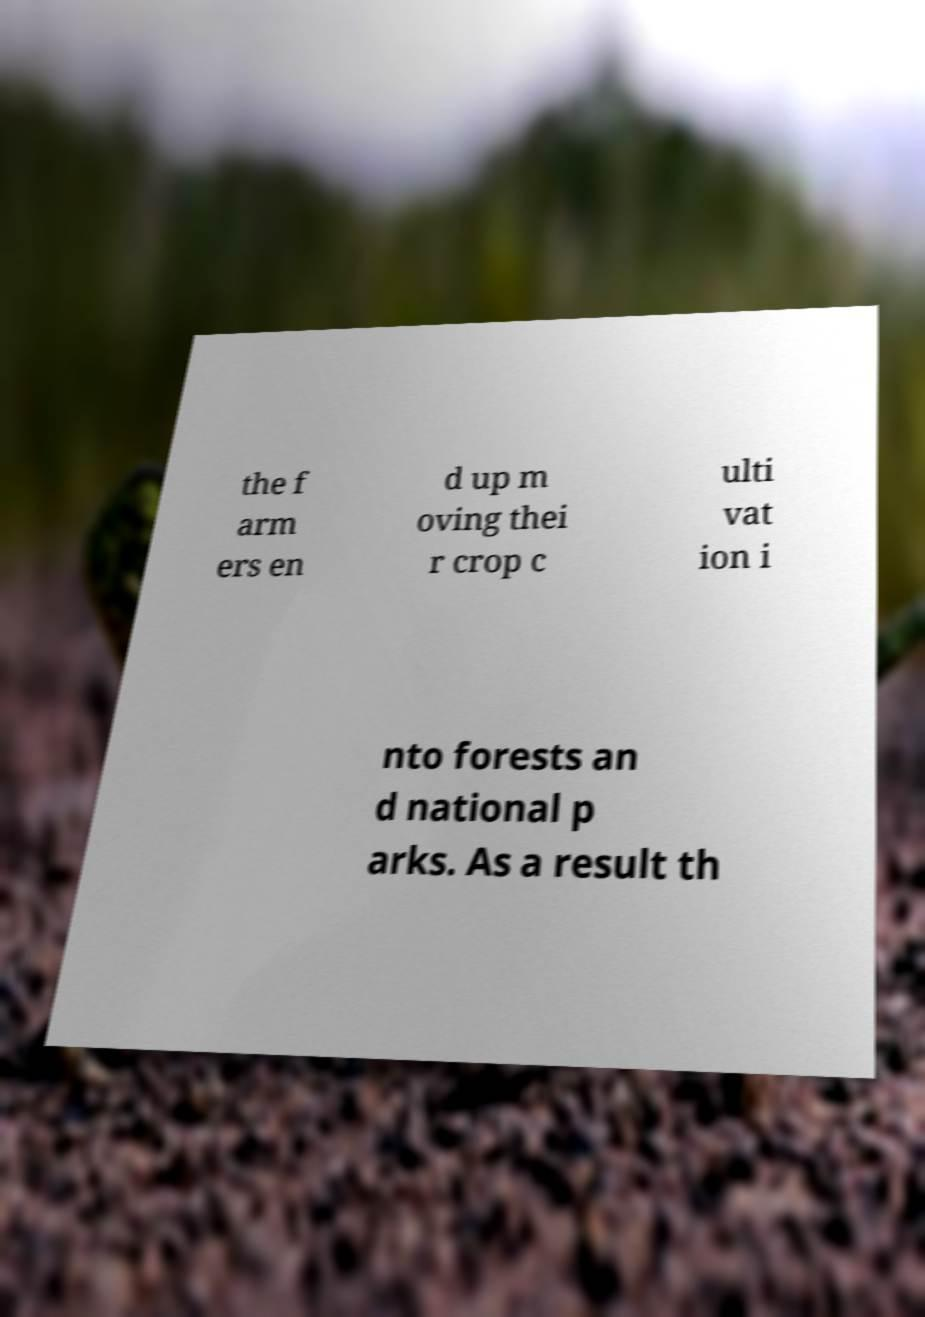Can you accurately transcribe the text from the provided image for me? the f arm ers en d up m oving thei r crop c ulti vat ion i nto forests an d national p arks. As a result th 